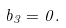<formula> <loc_0><loc_0><loc_500><loc_500>b _ { 3 } = 0 .</formula> 